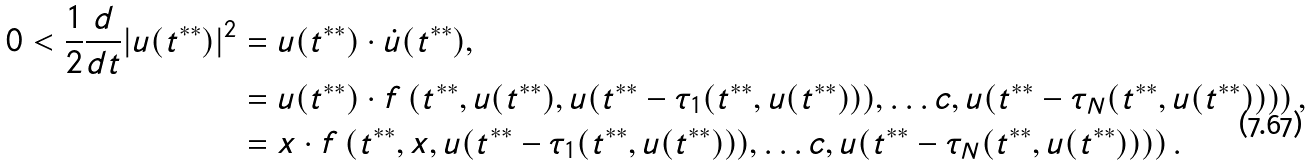<formula> <loc_0><loc_0><loc_500><loc_500>0 < \frac { 1 } { 2 } \frac { d } { d t } | u ( t ^ { * * } ) | ^ { 2 } & = u ( t ^ { * * } ) \cdot \dot { u } ( t ^ { * * } ) , \\ & = u ( t ^ { * * } ) \cdot f \left ( t ^ { * * } , u ( t ^ { * * } ) , u ( t ^ { * * } - \tau _ { 1 } ( t ^ { * * } , u ( t ^ { * * } ) ) ) , \dots c , u ( t ^ { * * } - \tau _ { N } ( t ^ { * * } , u ( t ^ { * * } ) ) ) \right ) , \\ & = x \cdot f \left ( t ^ { * * } , x , u ( t ^ { * * } - \tau _ { 1 } ( t ^ { * * } , u ( t ^ { * * } ) ) ) , \dots c , u ( t ^ { * * } - \tau _ { N } ( t ^ { * * } , u ( t ^ { * * } ) ) ) \right ) .</formula> 